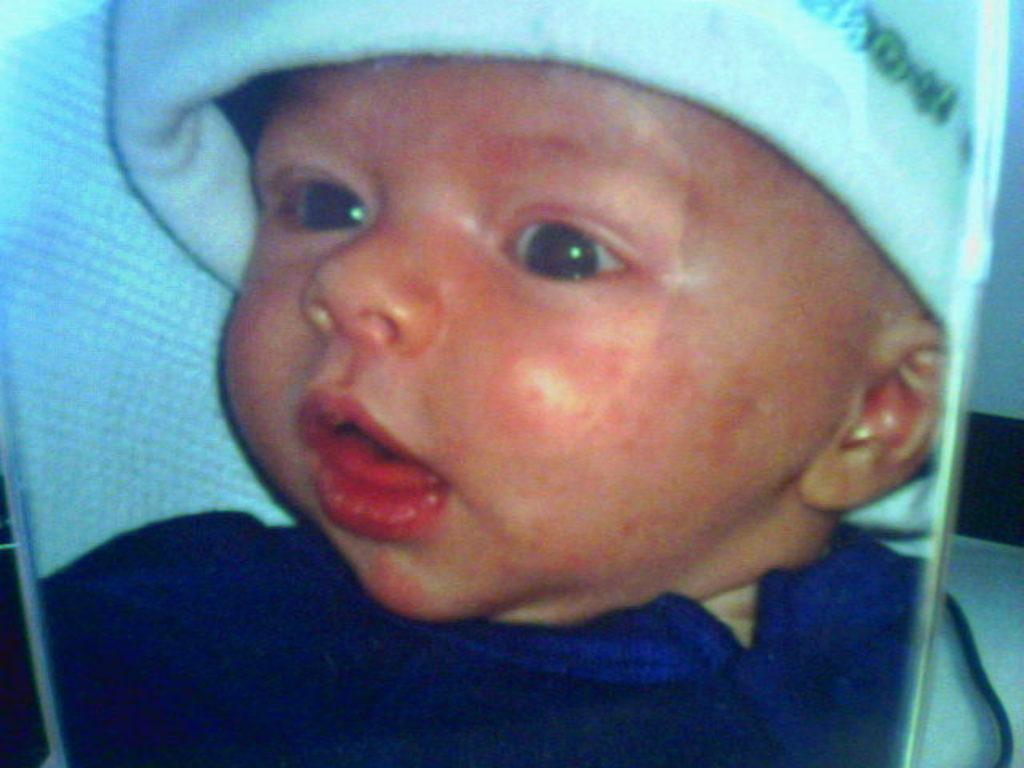Please provide a concise description of this image. In the foreground of this image, it seems like a photo of a baby. 